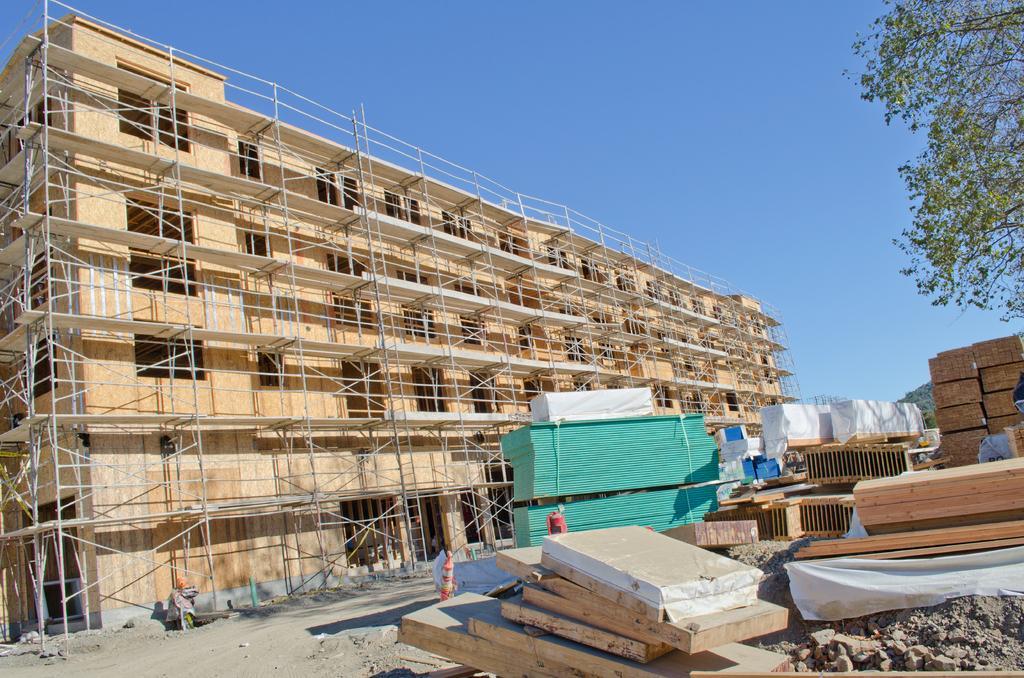Describe this image in one or two sentences. In this image there is a building under construction. On the right side there are wooden blocks and some construction materials. On the right side top there is a tree. At the top there is the sky. At the bottom there is sand. 